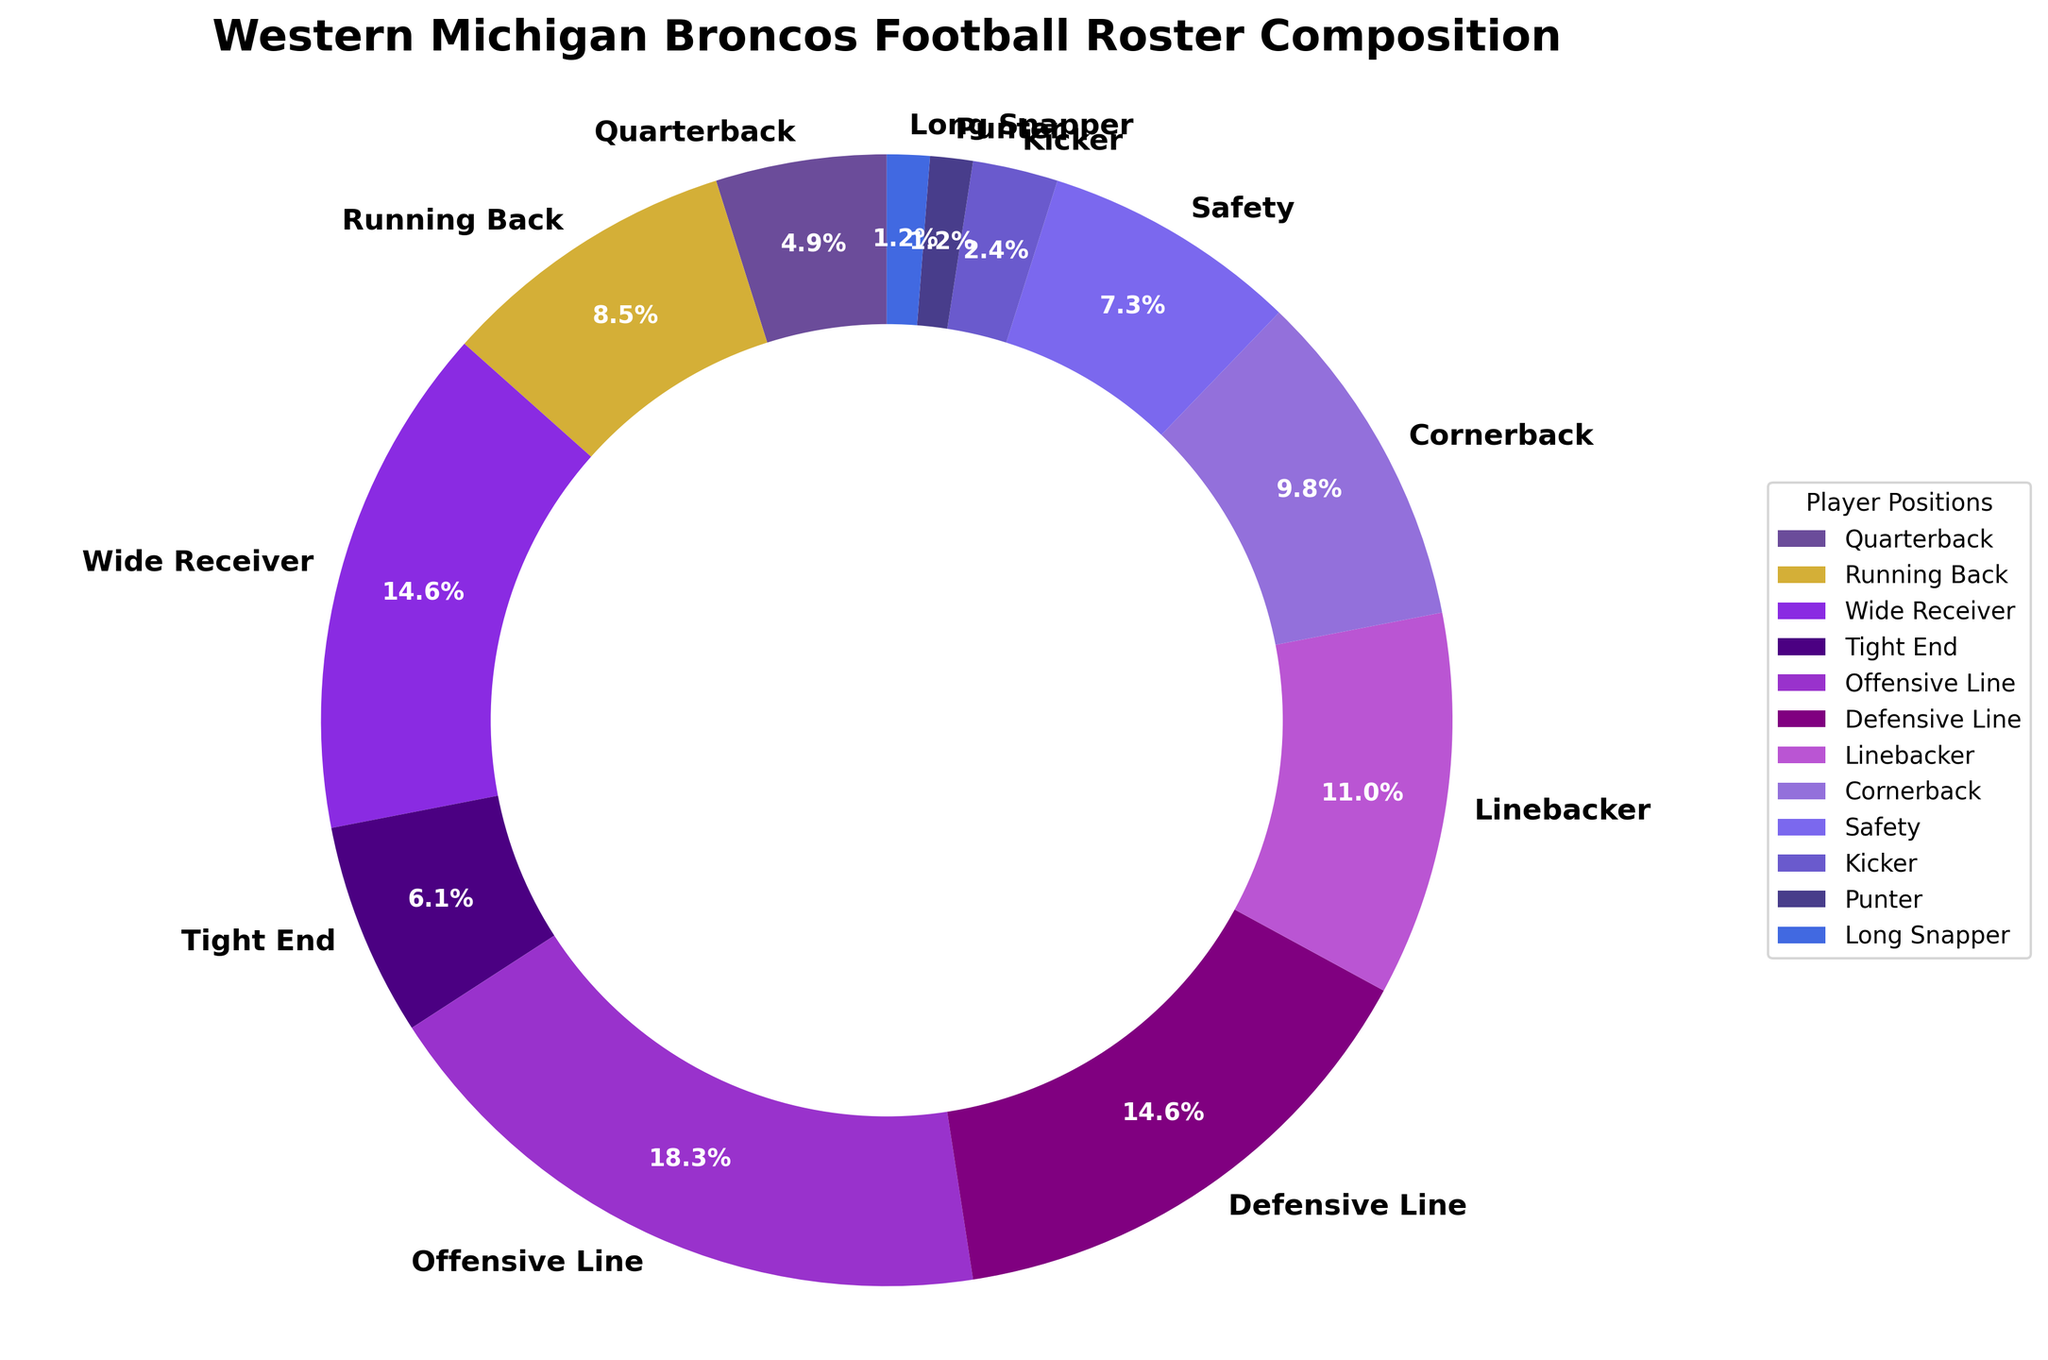Which position has the highest number of players? To determine this, observe the segment sizes and labels in the pie chart. The "Offensive Line" position has the largest segment, indicating the highest number of players.
Answer: Offensive Line What's the combined percentage of players for Wide Receiver and Defensive Line positions? First, locate the percentages for Wide Receiver and Defensive Line in the pie chart. Wide Receiver has 15.4% and Defensive Line has 15.4%. Sum these percentages to get the combined total. 15.4% + 15.4% = 30.8%.
Answer: 30.8% Are there more players in the Offensive Line than in all the Running Backs and Quarterbacks combined? The number of Offensive Line players is 15. For Running Back and Quarterback combined: 7 (Running Back) + 4 (Quarterback) = 11. Since 15 is greater than 11, the answer is yes.
Answer: Yes Which position has the smallest representation on the roster? Look for the smallest segment in the pie chart. The "Punter" and "Long Snapper" positions each have the smallest segment, indicating one player each.
Answer: Punter and Long Snapper What is the total percentage of players in the positions from Defensive Line, Linebacker, and Safety combined? Find the percentages for each of these positions: Defensive Line (15.4%), Linebacker (11.5%), and Safety (7.7%). Sum these percentages: 15.4% + 11.5% + 7.7% = 34.6%.
Answer: 34.6% Which position has exactly twice the number of players as the Quarterback position? Quarterback has 4 players. To find the position with twice this number: 4 * 2 = 8 players. Cornerback has exactly 8 players, matching this criterion.
Answer: Cornerback Is the number of Wide Receivers greater than the combined number of Running Backs and Safeties? Wide Receivers: 12 players. Combined Running Backs and Safeties: 7 (Running Back) + 6 (Safety) = 13 players. Since 12 is less than 13, the answer is no.
Answer: No What is the percentage difference between the positions with the most and the fewest players? The most players are in Offensive Line (15 players, 19.2%). The fewest players are in Punter and Long Snapper (each 1 player, 1.3%). Percentage difference: 19.2% - 1.3% = 17.9%.
Answer: 17.9% 